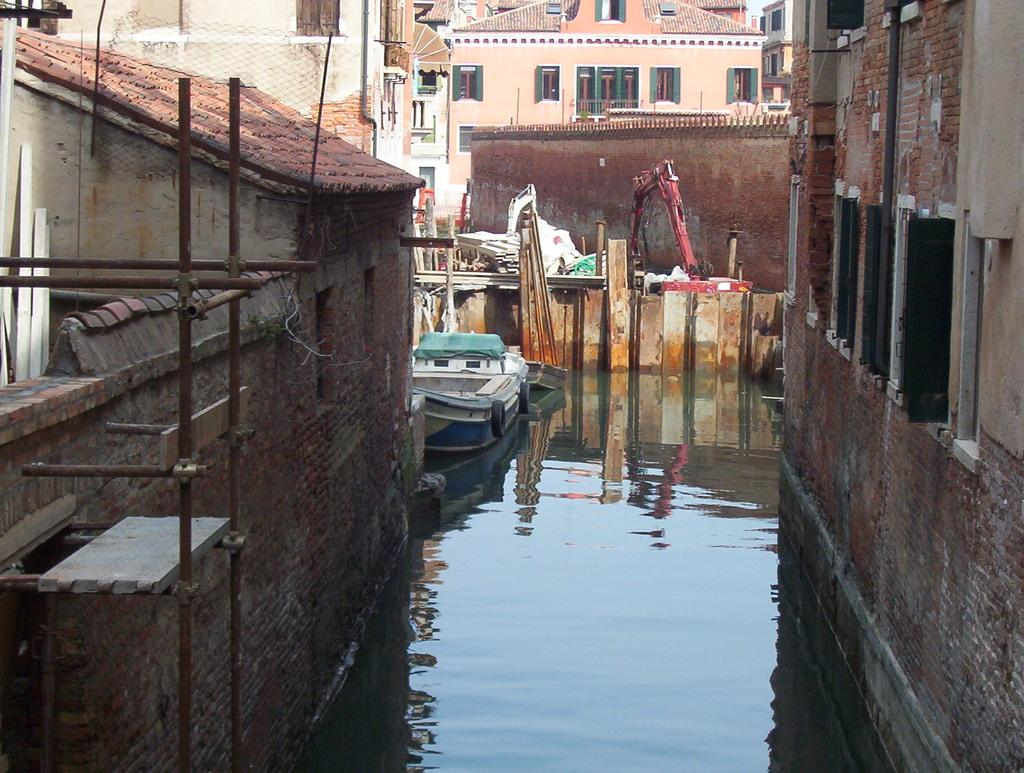What is the main subject of the image? The main subject of the image is a boat on the water. What other objects or structures can be seen in the image? There is an excavator, a wall, poles, buildings with windows, and some unspecified objects in the image. Can you describe the sweater worn by the boat in the image? There is no sweater present in the image, as boats do not wear clothing. 